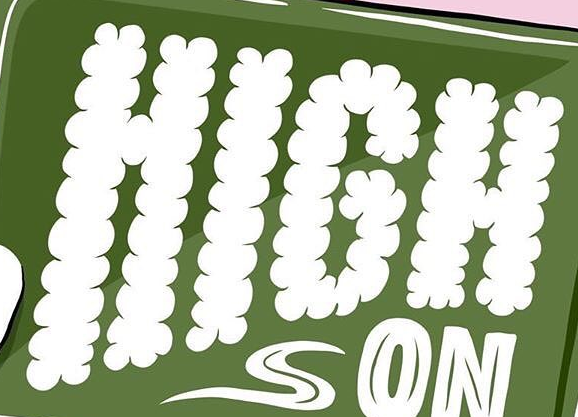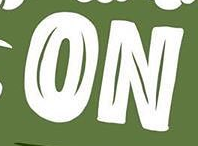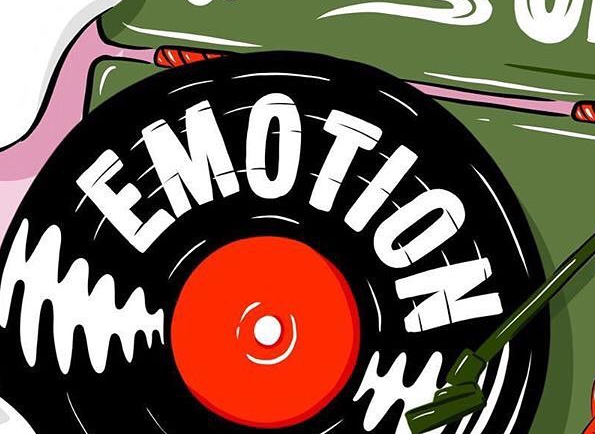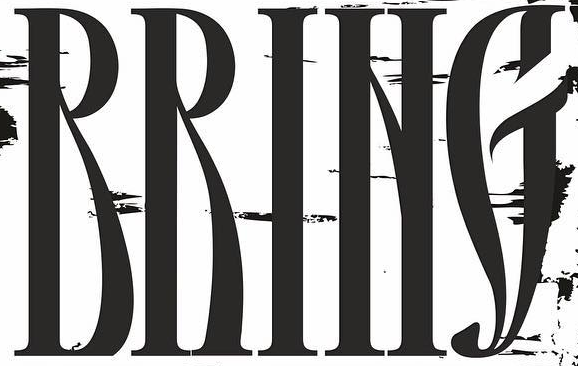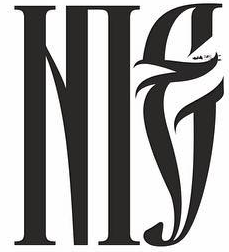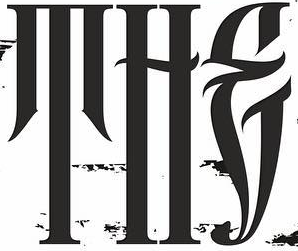Read the text from these images in sequence, separated by a semicolon. HIGH; ON; EMOTION; RRING; NIE; THE 